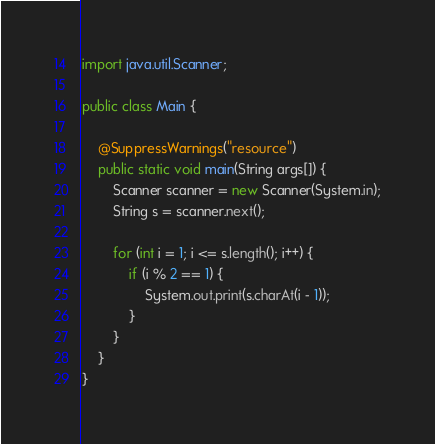<code> <loc_0><loc_0><loc_500><loc_500><_Java_>import java.util.Scanner;

public class Main {

	@SuppressWarnings("resource")
	public static void main(String args[]) {
		Scanner scanner = new Scanner(System.in);
		String s = scanner.next();

		for (int i = 1; i <= s.length(); i++) {
			if (i % 2 == 1) {
				System.out.print(s.charAt(i - 1));
			}
		}
	}
}
</code> 